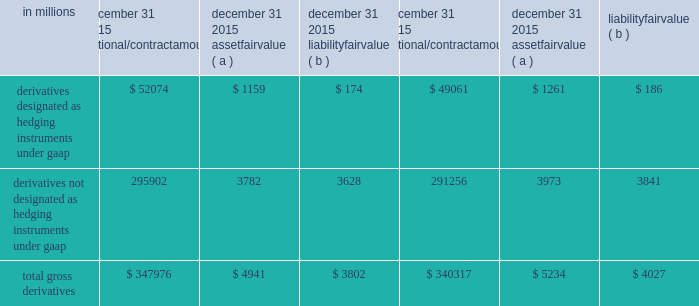In 2011 , we transferred approximately 1.3 million shares of blackrock series c preferred stock to blackrock in connection with our obligation .
In 2013 , we transferred an additional .2 million shares to blackrock .
At december 31 , 2015 , we held approximately 1.3 million shares of blackrock series c preferred stock which were available to fund our obligation in connection with the blackrock ltip programs .
See note 24 subsequent events for information on our february 1 , 2016 transfer of 0.5 million shares of the series c preferred stock to blackrock to satisfy a portion of our ltip obligation .
Pnc accounts for its blackrock series c preferred stock at fair value , which offsets the impact of marking-to-market the obligation to deliver these shares to blackrock .
The fair value of the blackrock series c preferred stock is included on our consolidated balance sheet in the caption other assets .
Additional information regarding the valuation of the blackrock series c preferred stock is included in note 7 fair value .
Note 14 financial derivatives we use derivative financial instruments ( derivatives ) primarily to help manage exposure to interest rate , market and credit risk and reduce the effects that changes in interest rates may have on net income , the fair value of assets and liabilities , and cash flows .
We also enter into derivatives with customers to facilitate their risk management activities .
Derivatives represent contracts between parties that usually require little or no initial net investment and result in one party delivering cash or another type of asset to the other party based on a notional amount and an underlying as specified in the contract .
Derivative transactions are often measured in terms of notional amount , but this amount is generally not exchanged and it is not recorded on the balance sheet .
The notional amount is the basis to which the underlying is applied to determine required payments under the derivative contract .
The underlying is a referenced interest rate ( commonly libor ) , security price , credit spread or other index .
Residential and commercial real estate loan commitments associated with loans to be sold also qualify as derivative instruments .
The table presents the notional amounts and gross fair values of all derivative assets and liabilities held by pnc : table 111 : total gross derivatives .
( a ) included in other assets on our consolidated balance sheet .
( b ) included in other liabilities on our consolidated balance sheet .
All derivatives are carried on our consolidated balance sheet at fair value .
Derivative balances are presented on the consolidated balance sheet on a net basis taking into consideration the effects of legally enforceable master netting agreements and , when appropriate , any related cash collateral exchanged with counterparties .
Further discussion regarding the offsetting rights associated with these legally enforceable master netting agreements is included in the offsetting , counterparty credit risk , and contingent features section below .
Any nonperformance risk , including credit risk , is included in the determination of the estimated net fair value of the derivatives .
Further discussion on how derivatives are accounted for is included in note 1 accounting policies .
Derivatives designated as hedging instruments under gaap certain derivatives used to manage interest rate and foreign exchange risk as part of our asset and liability risk management activities are designated as accounting hedges under gaap .
Derivatives hedging the risks associated with changes in the fair value of assets or liabilities are considered fair value hedges , derivatives hedging the variability of expected future cash flows are considered cash flow hedges , and derivatives hedging a net investment in a foreign subsidiary are considered net investment hedges .
Designating derivatives as accounting hedges allows for gains and losses on those derivatives , to the extent effective , to be recognized in the income statement in the same period the hedged items affect earnings .
180 the pnc financial services group , inc .
2013 form 10-k .
For 2015 , the fair value of total gross derivatives was what percent of notional value? 
Computations: (4941 / 347976)
Answer: 0.0142. 